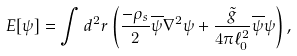Convert formula to latex. <formula><loc_0><loc_0><loc_500><loc_500>E [ \psi ] = \int d ^ { 2 } { r } \left ( \frac { - \rho _ { s } } { 2 } \overline { \psi } \nabla ^ { 2 } \psi + \frac { \tilde { g } } { 4 \pi \ell _ { 0 } ^ { 2 } } \overline { \psi } \psi \right ) ,</formula> 